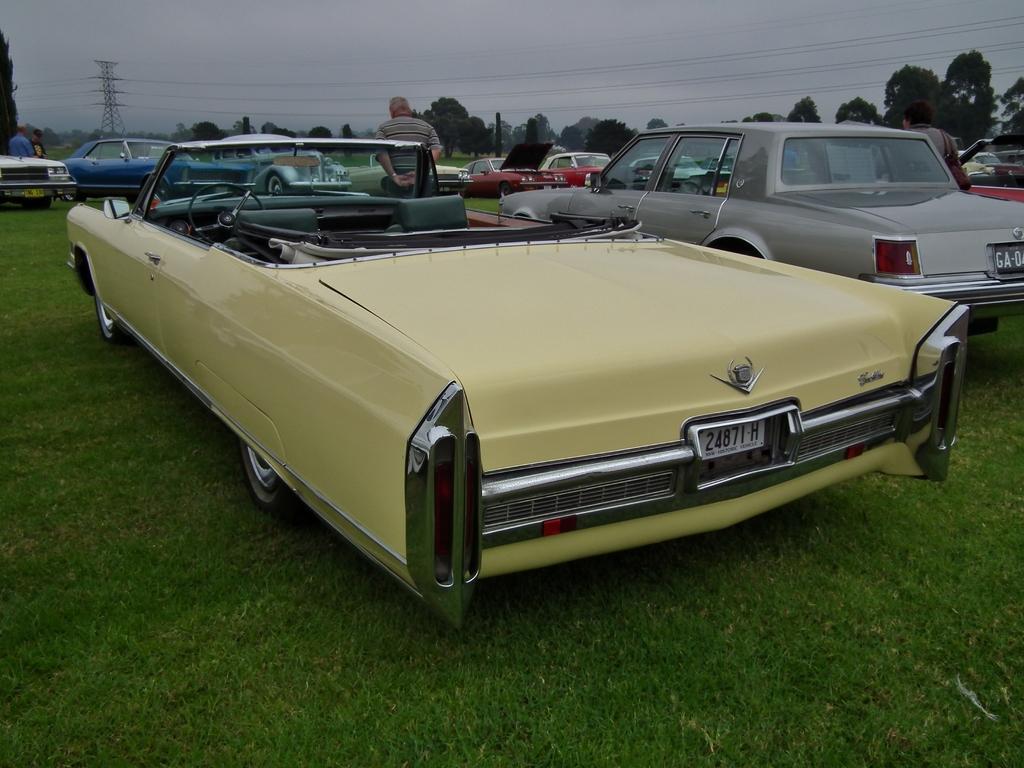How would you summarize this image in a sentence or two? In this image we can see vehicles on the grass on the ground and there are few persons standing. In the background there are trees, wires, tower and clouds in the sky. 